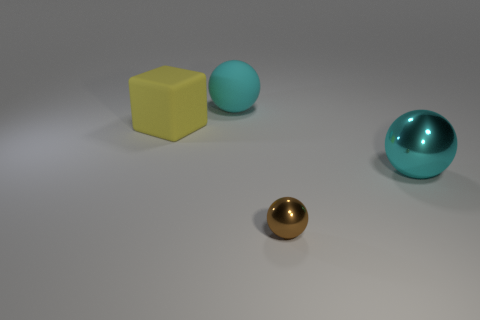Add 1 metallic spheres. How many objects exist? 5 Subtract all brown spheres. How many spheres are left? 2 Subtract all big balls. How many balls are left? 1 Subtract all spheres. How many objects are left? 1 Subtract 1 blocks. How many blocks are left? 0 Add 1 small yellow matte cubes. How many small yellow matte cubes exist? 1 Subtract 0 brown cylinders. How many objects are left? 4 Subtract all red blocks. Subtract all gray cylinders. How many blocks are left? 1 Subtract all gray blocks. How many blue spheres are left? 0 Subtract all blue rubber things. Subtract all big cyan matte balls. How many objects are left? 3 